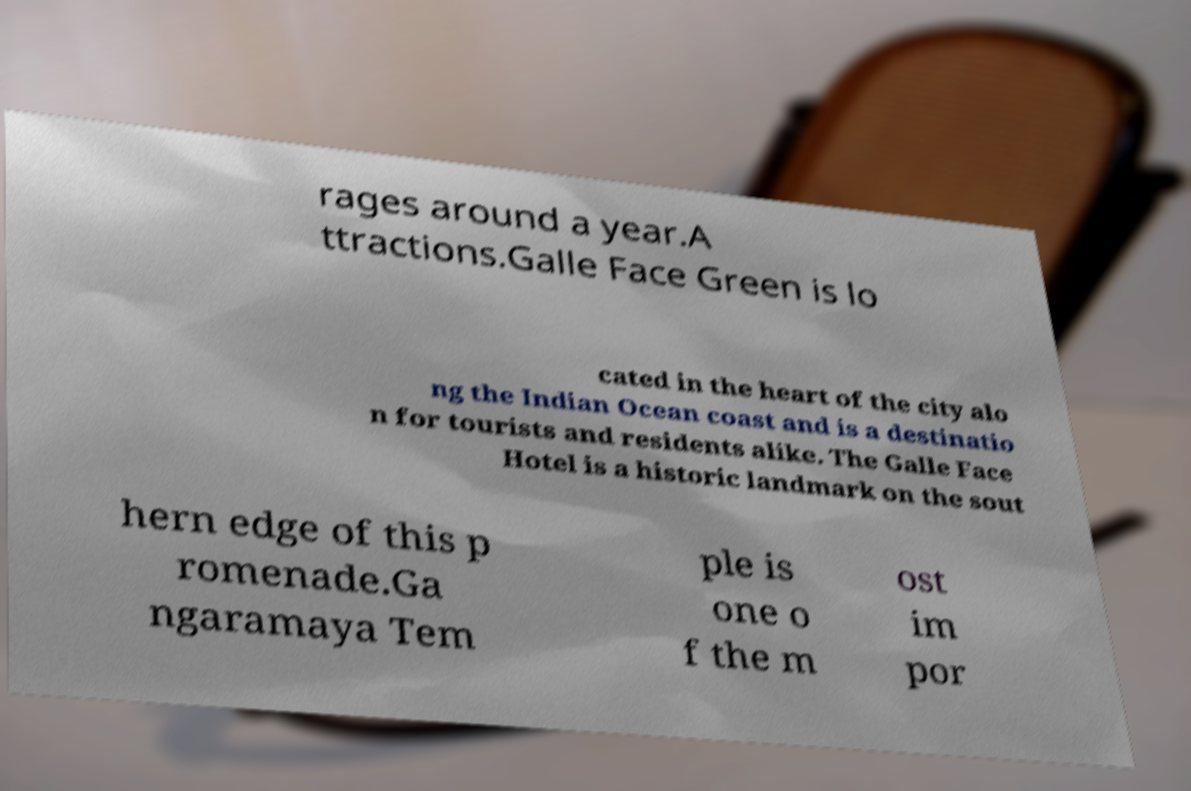Please identify and transcribe the text found in this image. rages around a year.A ttractions.Galle Face Green is lo cated in the heart of the city alo ng the Indian Ocean coast and is a destinatio n for tourists and residents alike. The Galle Face Hotel is a historic landmark on the sout hern edge of this p romenade.Ga ngaramaya Tem ple is one o f the m ost im por 